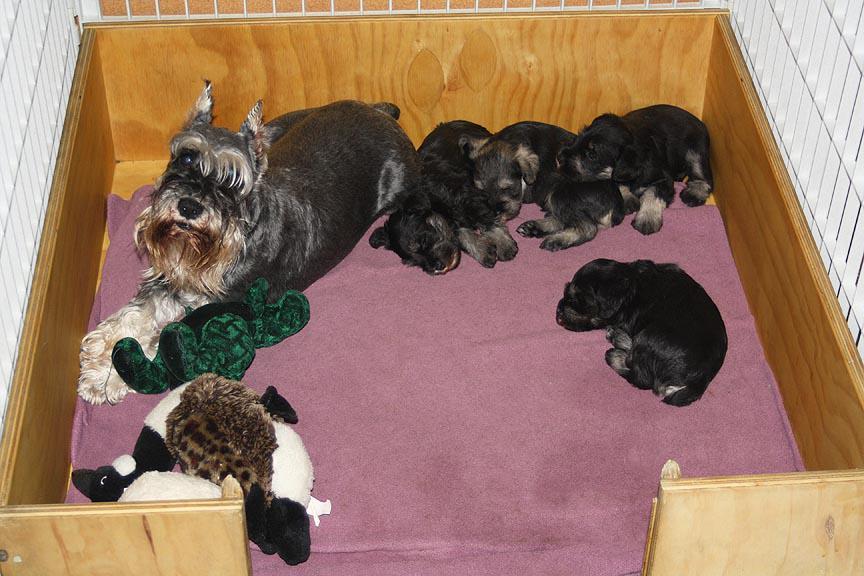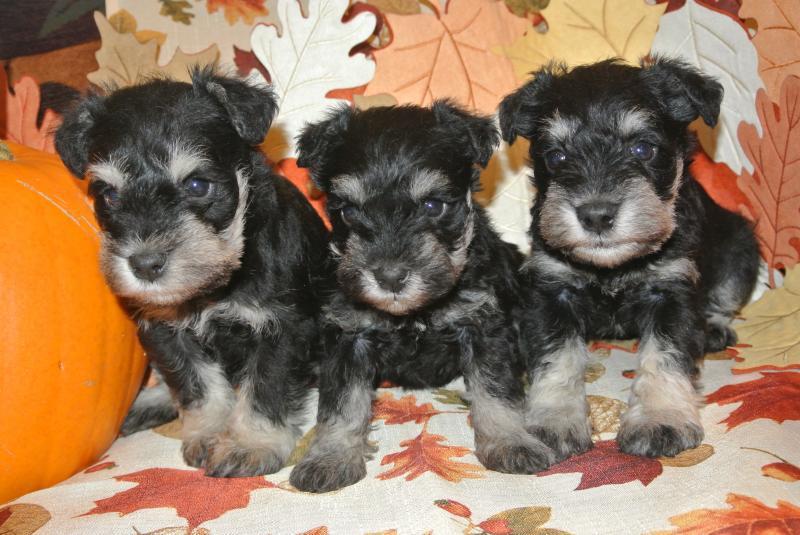The first image is the image on the left, the second image is the image on the right. For the images displayed, is the sentence "A wooden box with pink blankets is full of puppies" factually correct? Answer yes or no. Yes. The first image is the image on the left, the second image is the image on the right. Considering the images on both sides, is "An image shows a mother dog in a wood-sided crate with several puppies." valid? Answer yes or no. Yes. 